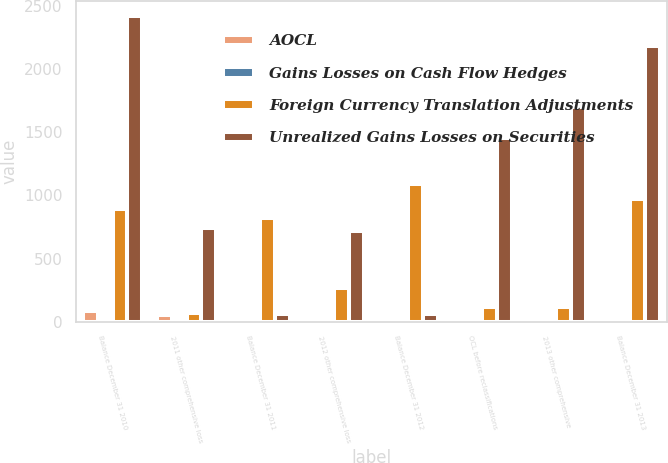Convert chart to OTSL. <chart><loc_0><loc_0><loc_500><loc_500><stacked_bar_chart><ecel><fcel>Balance December 31 2010<fcel>2011 other comprehensive loss<fcel>Balance December 31 2011<fcel>2012 other comprehensive loss<fcel>Balance December 31 2012<fcel>OCL before reclassifications<fcel>2013 other comprehensive<fcel>Balance December 31 2013<nl><fcel>AOCL<fcel>85<fcel>59<fcel>26<fcel>20<fcel>6<fcel>11<fcel>3<fcel>9<nl><fcel>Gains Losses on Cash Flow Hedges<fcel>4<fcel>1<fcel>3<fcel>4<fcel>7<fcel>8<fcel>8<fcel>15<nl><fcel>Foreign Currency Translation Adjustments<fcel>892<fcel>71<fcel>821<fcel>271<fcel>1092<fcel>118<fcel>118<fcel>974<nl><fcel>Unrealized Gains Losses on Securities<fcel>2417<fcel>745<fcel>65<fcel>718<fcel>65<fcel>1453<fcel>1697<fcel>2183<nl></chart> 